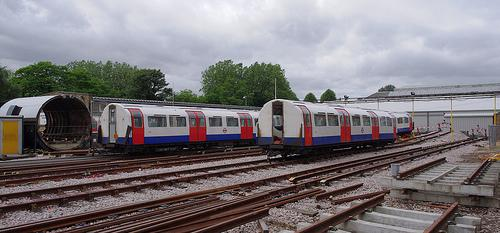Question: what is shown?
Choices:
A. Bus.
B. Subway.
C. Airplane.
D. Train.
Answer with the letter. Answer: D Question: how many trains are there?
Choices:
A. 1.
B. 3.
C. 2.
D. 4.
Answer with the letter. Answer: C Question: where are the trains?
Choices:
A. Track.
B. Station.
C. Mountains.
D. City.
Answer with the letter. Answer: A Question: what color are the windows?
Choices:
A. Blue.
B. White.
C. Red.
D. Black.
Answer with the letter. Answer: C Question: when was the photo taken?
Choices:
A. Morning.
B. Night.
C. Afternoon.
D. Sunrise.
Answer with the letter. Answer: A Question: why is the sky overcast?
Choices:
A. Rain.
B. Cloudy.
C. Cold.
D. Winter.
Answer with the letter. Answer: A 